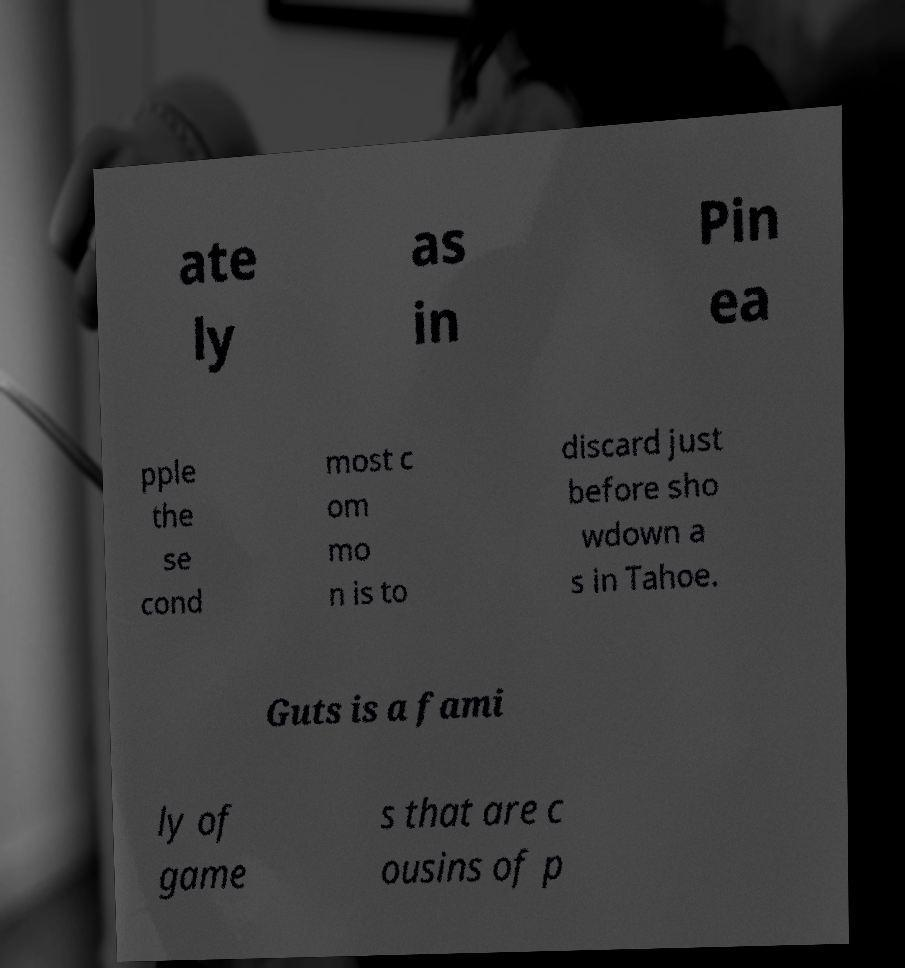Can you read and provide the text displayed in the image?This photo seems to have some interesting text. Can you extract and type it out for me? ate ly as in Pin ea pple the se cond most c om mo n is to discard just before sho wdown a s in Tahoe. Guts is a fami ly of game s that are c ousins of p 